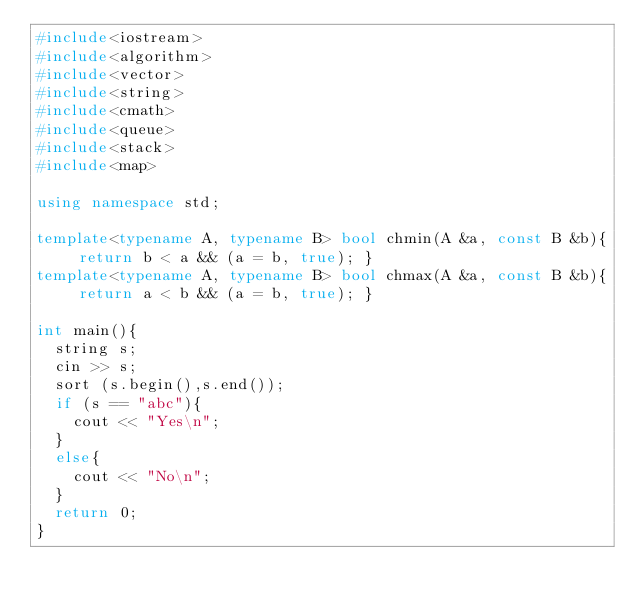<code> <loc_0><loc_0><loc_500><loc_500><_C++_>#include<iostream>
#include<algorithm>
#include<vector>
#include<string>
#include<cmath>
#include<queue>
#include<stack>
#include<map>

using namespace std;

template<typename A, typename B> bool chmin(A &a, const B &b){ return b < a && (a = b, true); }
template<typename A, typename B> bool chmax(A &a, const B &b){ return a < b && (a = b, true); }

int main(){
  string s;
  cin >> s;
  sort (s.begin(),s.end());
  if (s == "abc"){
    cout << "Yes\n";
  }
  else{
    cout << "No\n";
  }
  return 0;
}</code> 